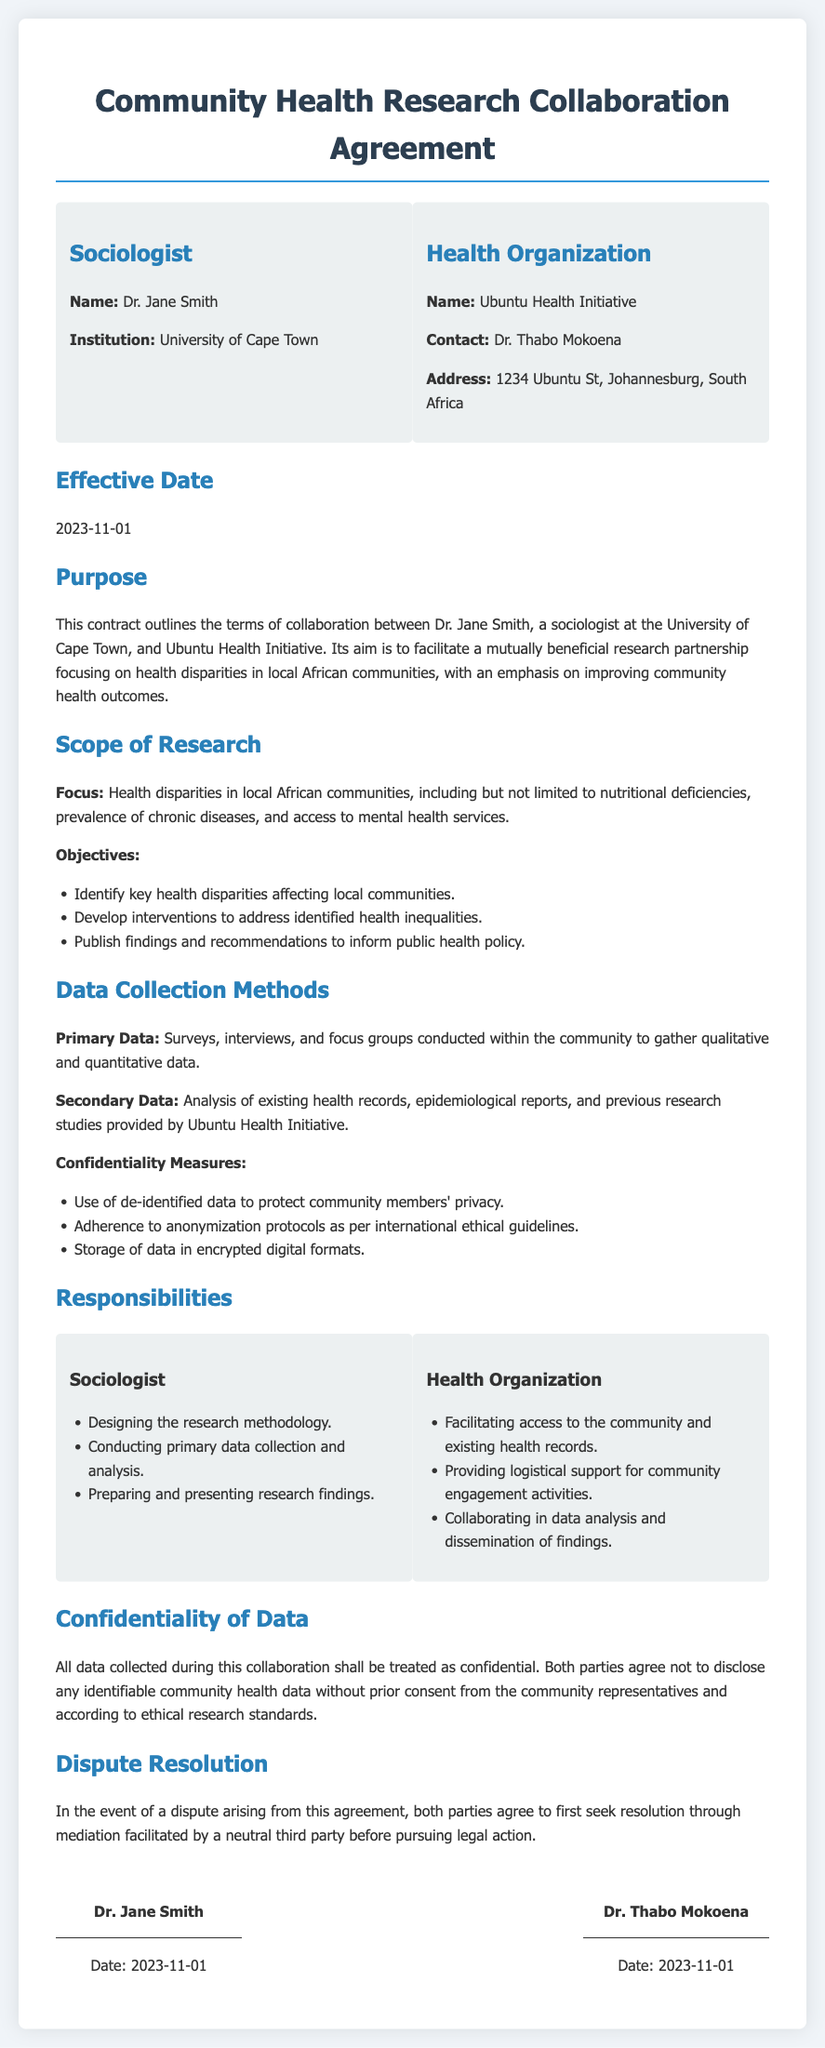What is the name of the sociologist? The document specifies the sociologist's name as Dr. Jane Smith.
Answer: Dr. Jane Smith What is the effective date of the agreement? The effective date mentioned in the document is 2023-11-01.
Answer: 2023-11-01 What organization is collaborating with the sociologist? The collaborating organization identified in the document is Ubuntu Health Initiative.
Answer: Ubuntu Health Initiative What is one objective of the research? The document lists objectives including identifying key health disparities.
Answer: Identify key health disparities What methods are used for primary data collection? The document states that surveys, interviews, and focus groups are used for primary data collection.
Answer: Surveys, interviews, and focus groups What confidentiality measure is mentioned in the document? The document mentions the use of de-identified data to protect privacy as a confidentiality measure.
Answer: Use of de-identified data Who is responsible for facilitating access to the community? It is stated that the Health Organization is responsible for facilitating access to the community.
Answer: Health Organization What is the purpose of this contract? The document describes the purpose as facilitating a mutually beneficial research partnership focusing on health disparities.
Answer: Facilitate a mutually beneficial research partnership What is the method of dispute resolution outlined? The agreement specifies that disputes will first seek resolution through mediation.
Answer: Mediation What type of data is analyzed as secondary data? The document includes analysis of existing health records as part of secondary data.
Answer: Existing health records 